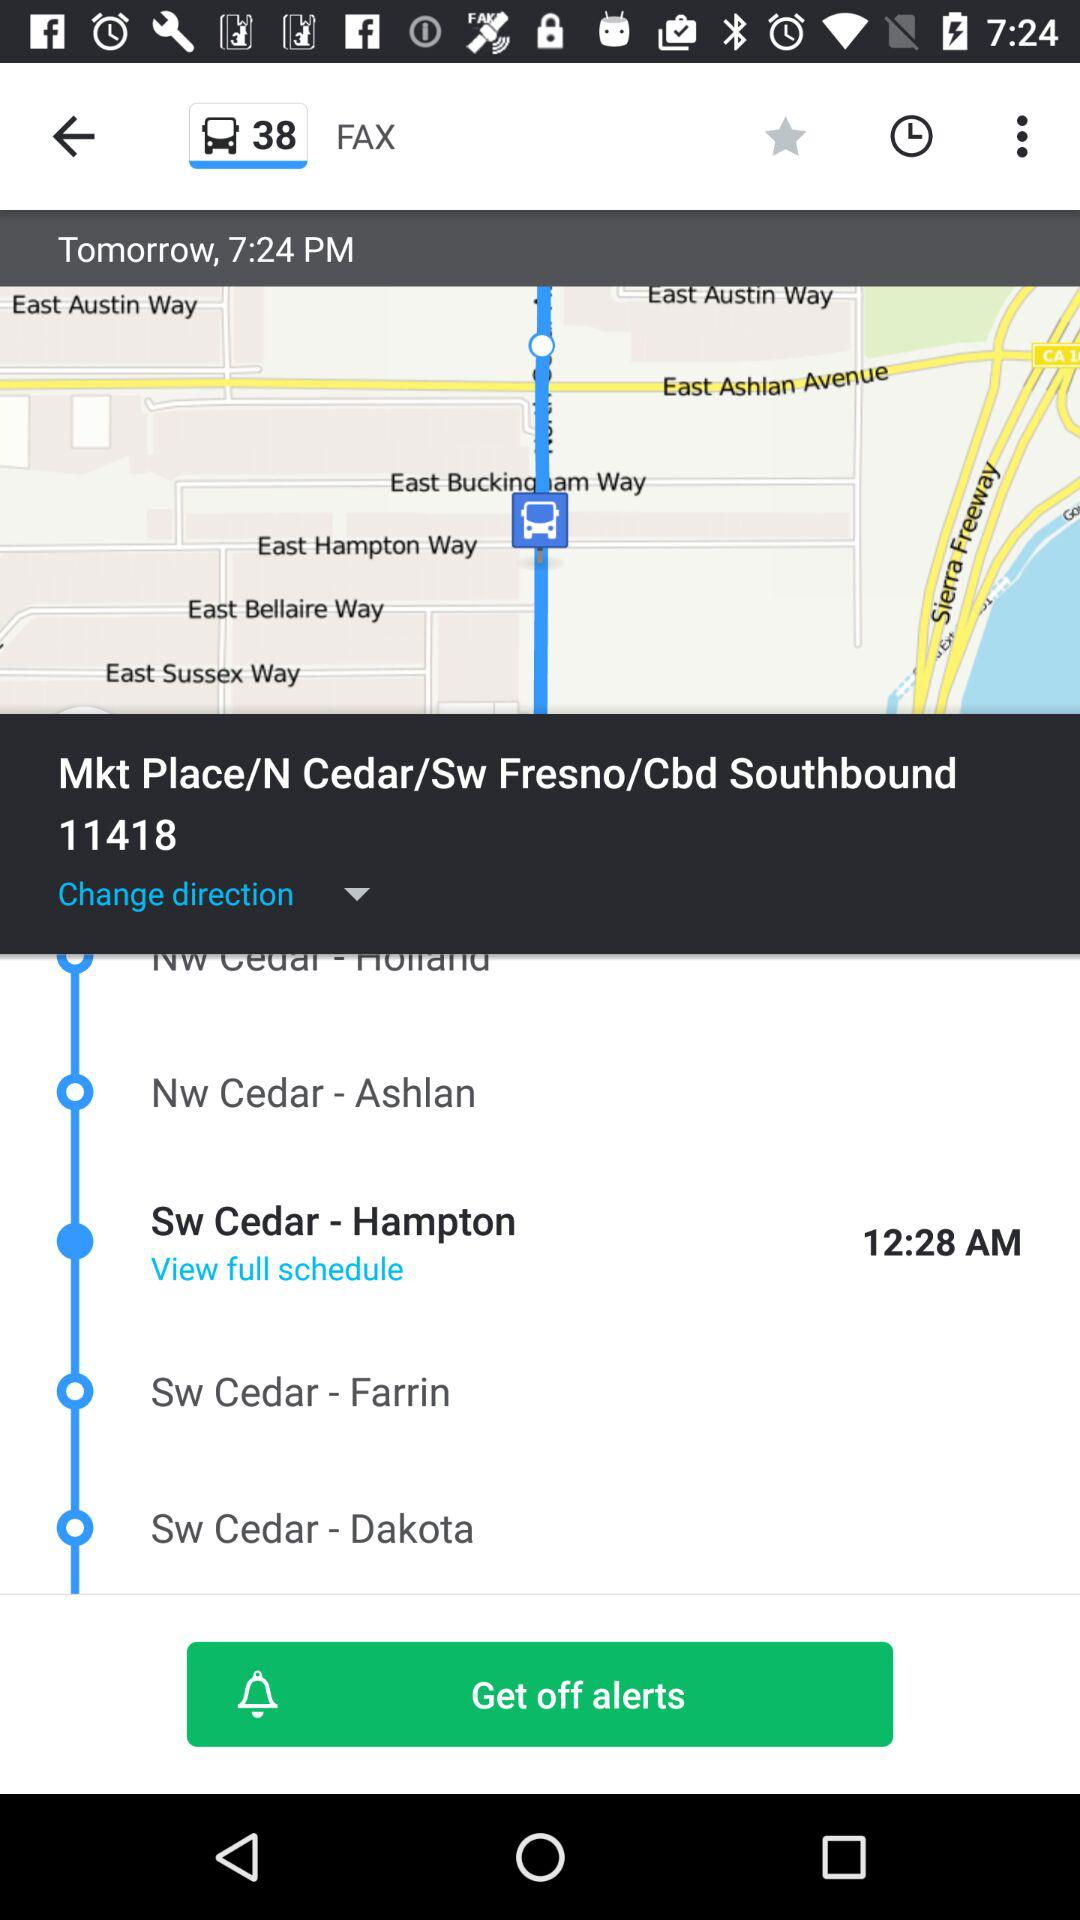What is the given time for tomorrow? The given time for tomorrow is 7:24 PM. 